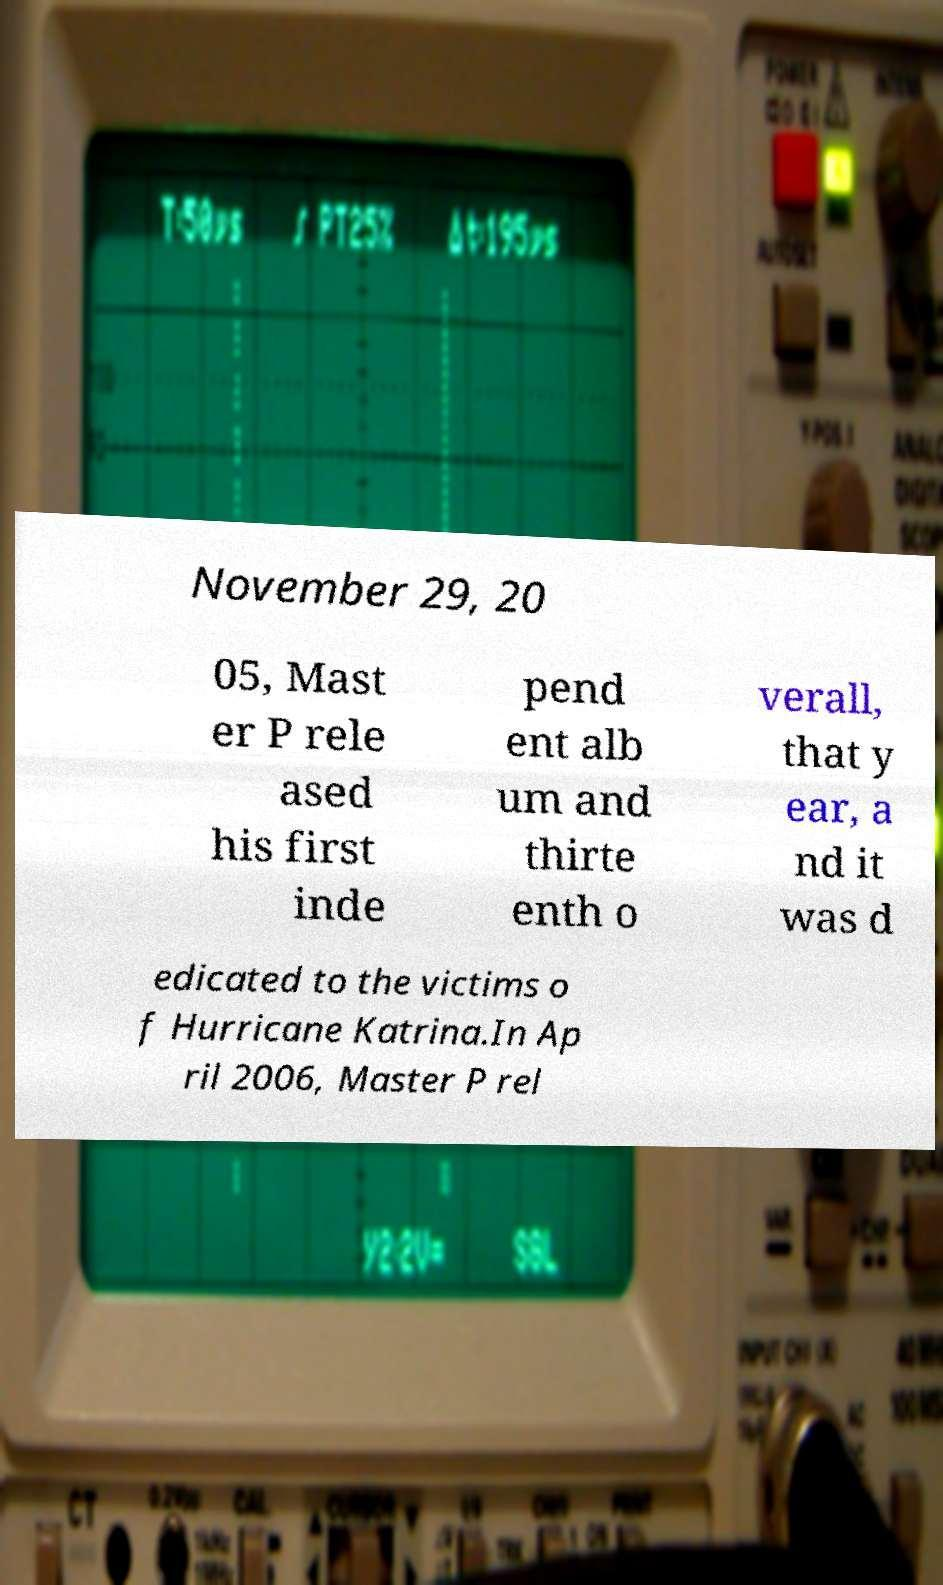Could you extract and type out the text from this image? November 29, 20 05, Mast er P rele ased his first inde pend ent alb um and thirte enth o verall, that y ear, a nd it was d edicated to the victims o f Hurricane Katrina.In Ap ril 2006, Master P rel 